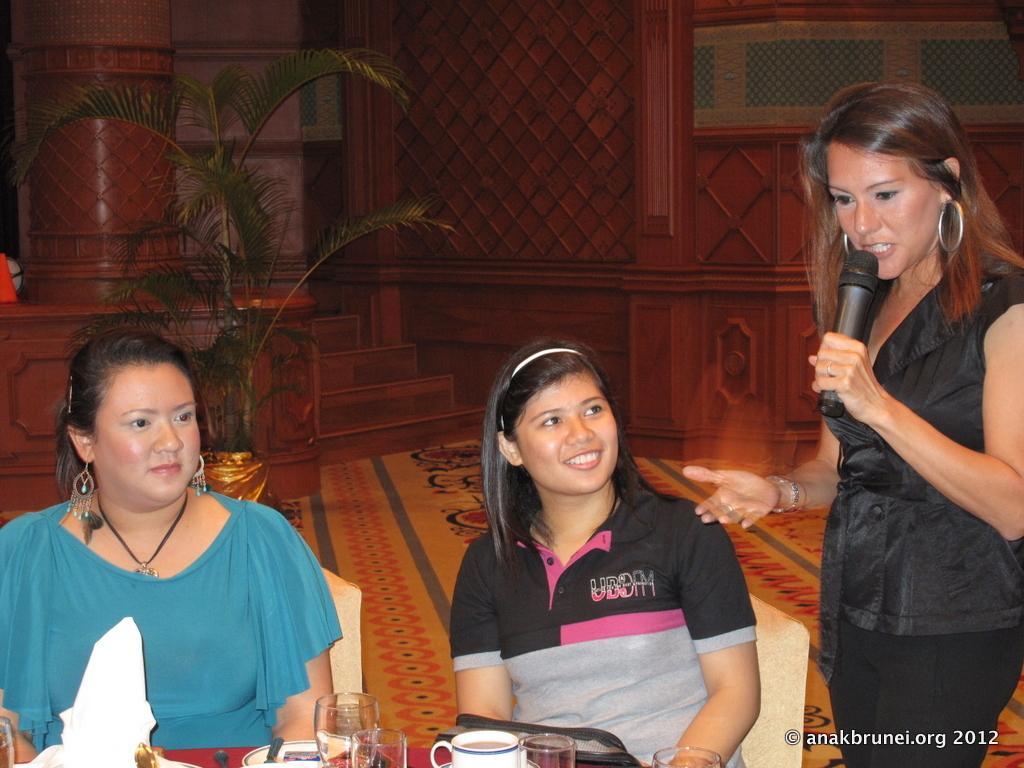In one or two sentences, can you explain what this image depicts? On the left side, there is a woman in blue color t-shirt sitting on a chair in front of a table near another woman who is sitting on another chair in front of a table on which, there are glasses, a cup and other objects. On the right side, there is a woman in black color dress holding a mic and speaking. In the right bottom corner, there is watermark. In the background, there is a carpet on the floor and there is wall. 